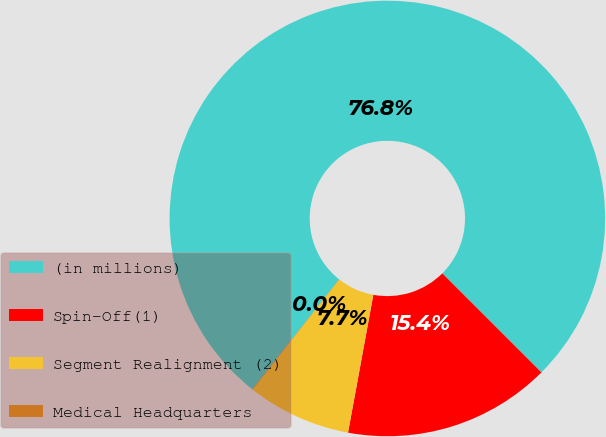Convert chart to OTSL. <chart><loc_0><loc_0><loc_500><loc_500><pie_chart><fcel>(in millions)<fcel>Spin-Off(1)<fcel>Segment Realignment (2)<fcel>Medical Headquarters<nl><fcel>76.84%<fcel>15.4%<fcel>7.72%<fcel>0.04%<nl></chart> 